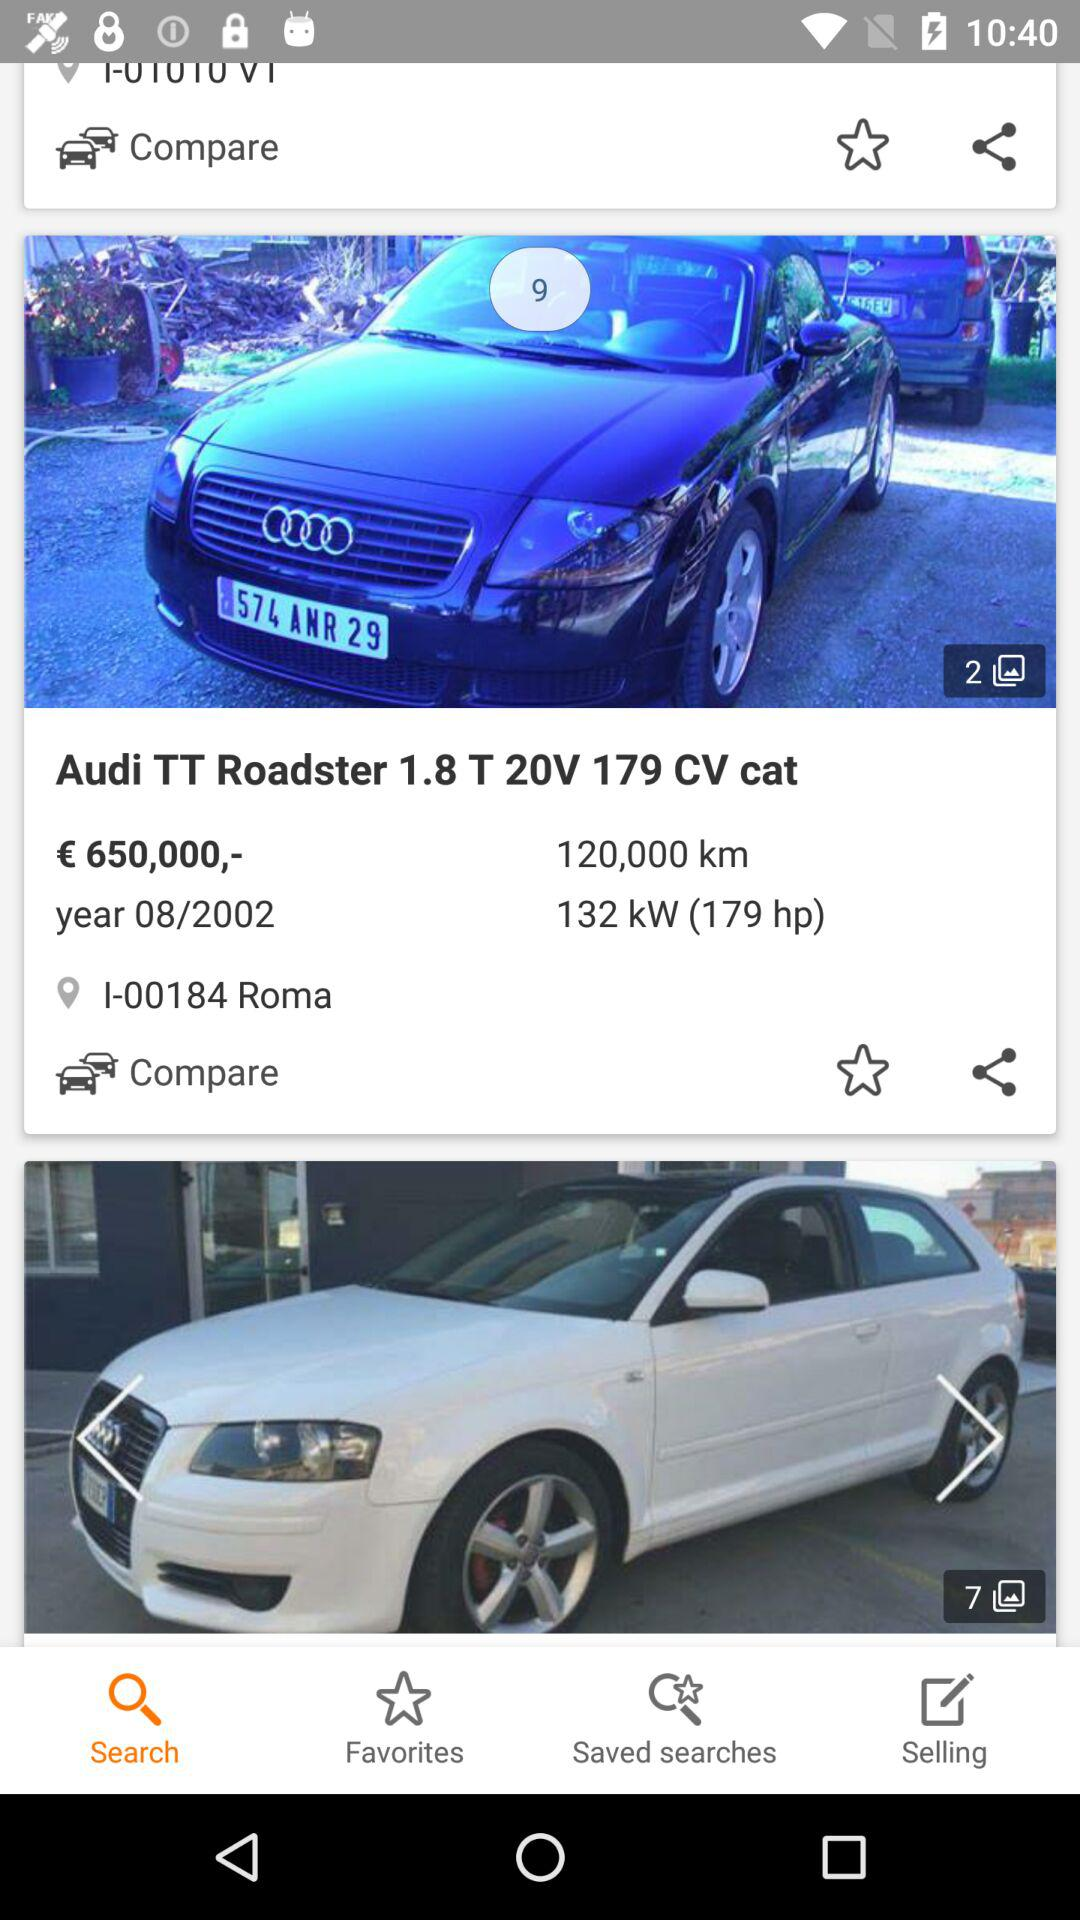What is the location of the "Audi TT Roadster"? The location is I-00184 Roma. 